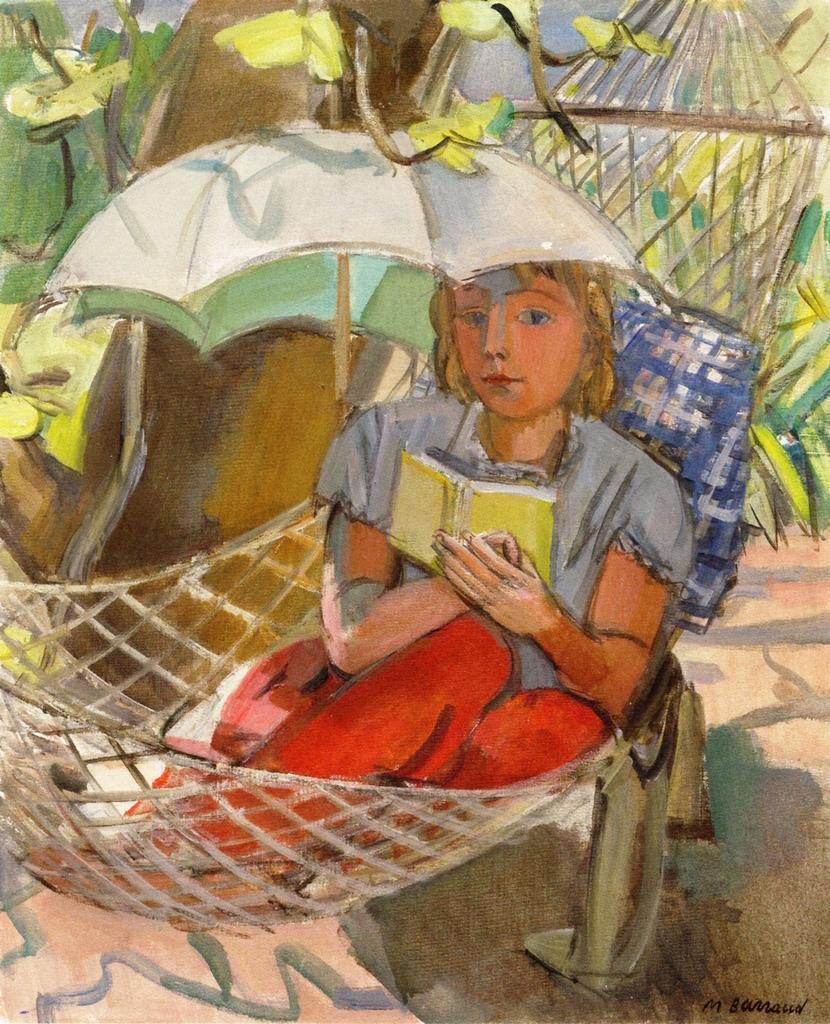How would you summarize this image in a sentence or two? In this image we can see there is a poster with a painting. And there is a person sitting on the object. There is a pillow, umbrella, cloth, flowers and tree. 